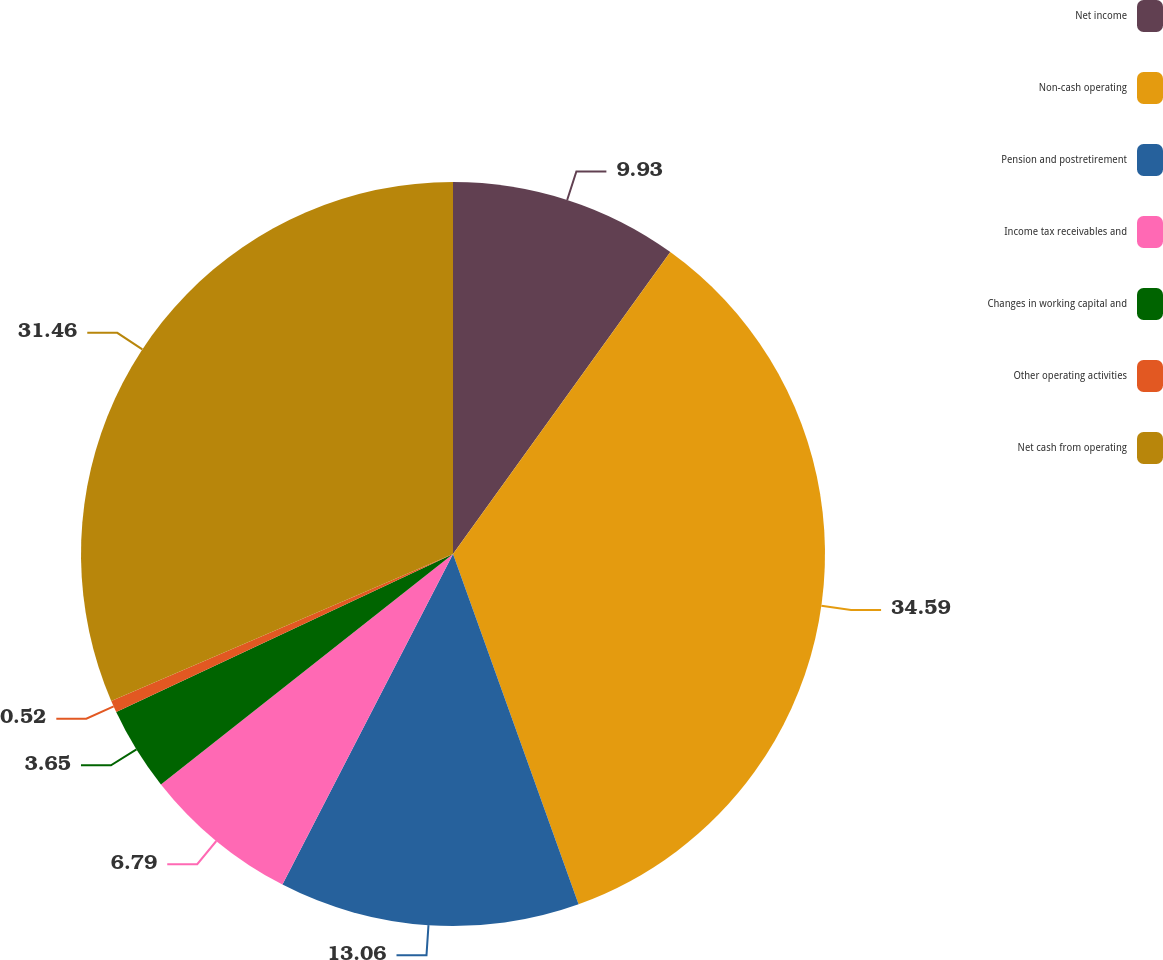<chart> <loc_0><loc_0><loc_500><loc_500><pie_chart><fcel>Net income<fcel>Non-cash operating<fcel>Pension and postretirement<fcel>Income tax receivables and<fcel>Changes in working capital and<fcel>Other operating activities<fcel>Net cash from operating<nl><fcel>9.93%<fcel>34.59%<fcel>13.06%<fcel>6.79%<fcel>3.65%<fcel>0.52%<fcel>31.46%<nl></chart> 